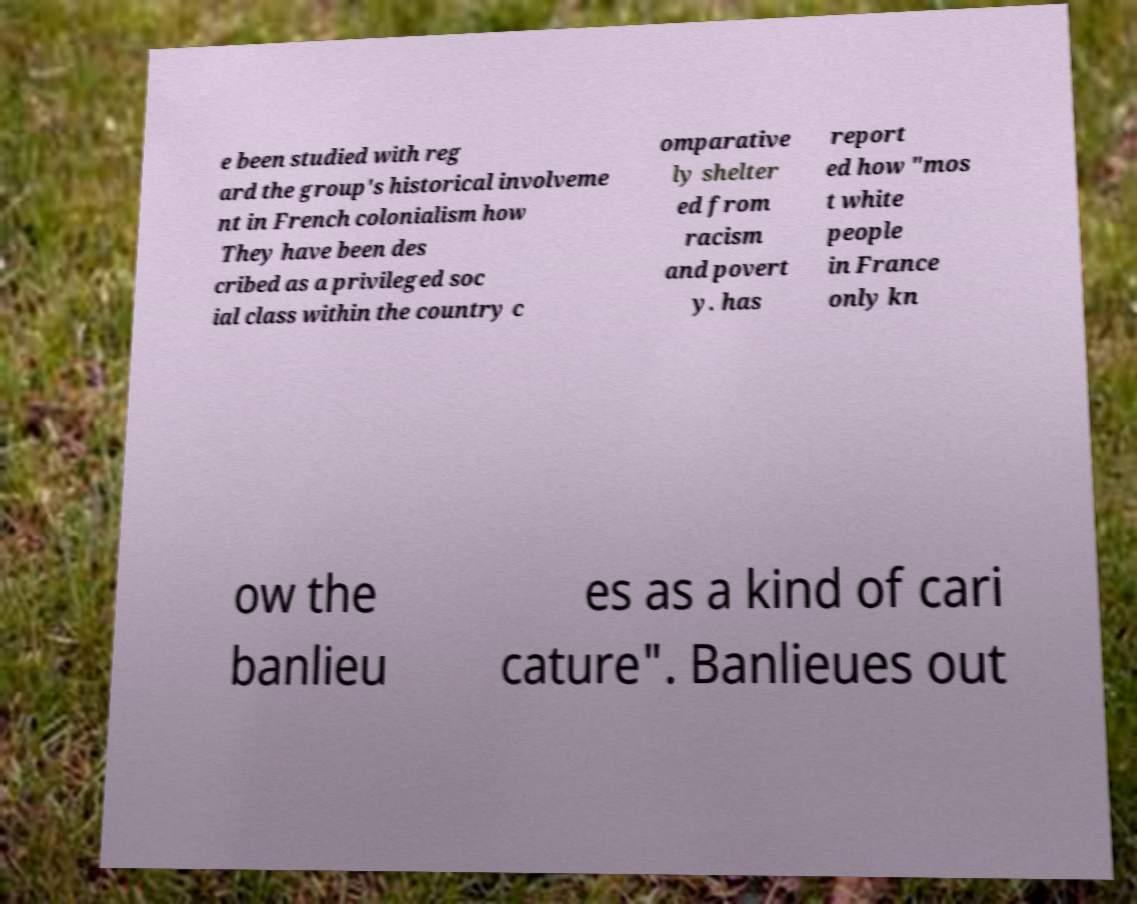Please read and relay the text visible in this image. What does it say? e been studied with reg ard the group's historical involveme nt in French colonialism how They have been des cribed as a privileged soc ial class within the country c omparative ly shelter ed from racism and povert y. has report ed how "mos t white people in France only kn ow the banlieu es as a kind of cari cature". Banlieues out 